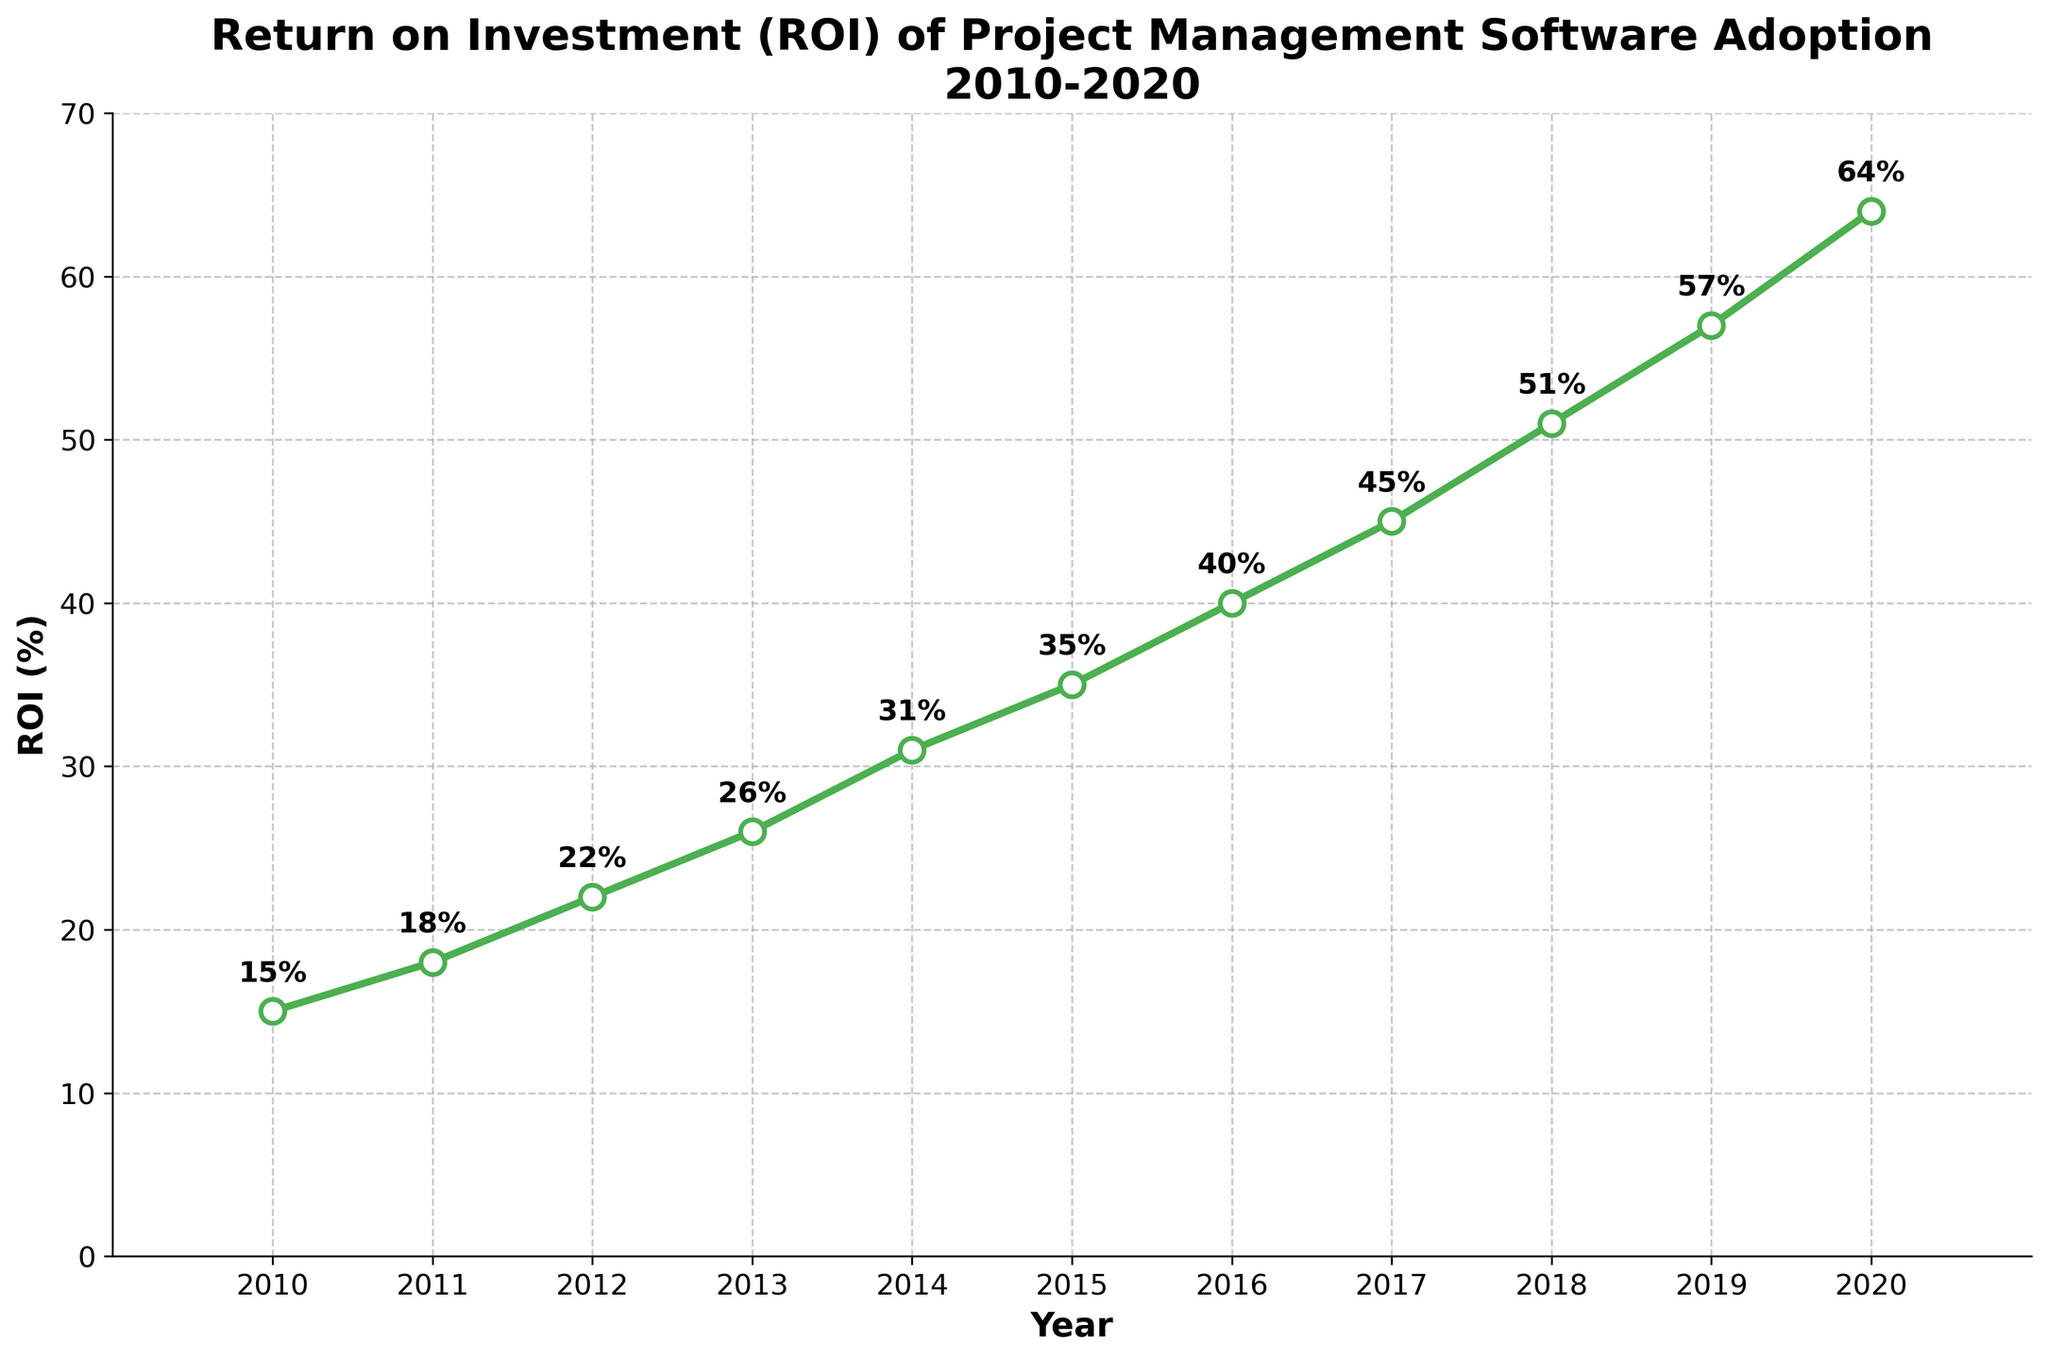What's the maximum ROI within the period? The highest point on the plot represents the maximum ROI. By looking at the y-axis values of the data points, the highest value is found at the year 2020.
Answer: 64% What's the difference in ROI between 2016 and 2020? To find the difference, locate the ROI values for 2016 and 2020 from the plot, which are 40% and 64% respectively. Then subtract the ROI of 2016 from 2020. 64% - 40% = 24%.
Answer: 24% In which year did the ROI first exceed 50%? The y-axis labels and data points show the progression of ROI over the years. The ROI first exceeds 50% at 2018 where the graph marks the ROI at 51%.
Answer: 2018 What's the average ROI over the period from 2010 to 2020? Add up all the ROI percentages from 2010 to 2020, which are 15%, 18%, 22%, 26%, 31%, 35%, 40%, 45%, 51%, 57%, and 64%. Then divide by the number of years, which is 11. (15+18+22+26+31+35+40+45+51+57+64)/11 = 36.27%.
Answer: 36.27% How much did the ROI increase from 2010 to 2011? Locate the ROI values for 2010 and 2011 from the plot, which are 15% and 18% respectively. Then subtract the ROI of 2010 from 2011. 18% - 15% = 3%.
Answer: 3% Between which two consecutive years was the smallest increase in ROI observed? Examine the differences between consecutive years by observing the distance between data points on the plot. Measure each yearly increase. The smallest increment is between 2010 and 2011 which is 3% (15% to 18%).
Answer: 2010-2011 What is the range of ROI values observed in the chart? The range is the difference between the maximum and minimum ROI values. The plot shows a minimum value of 15% in 2010 and a maximum of 64% in 2020. 64% - 15% = 49%.
Answer: 49% Which year marks the midpoint (median) of the observation period? What was the ROI in that year? The observation period from 2010 to 2020 has 11 years. The median year is the 6th year when sorted chronologically, which is 2015. The ROI in 2015 is 35%.
Answer: 2015, 35% How does the ROI trend overall across the entire period? By examining the overall direction of the plotted line, which consistently rises from 2010 to 2020, indicates a continuous increase in ROI over the years.
Answer: Increasing In what year did the ROI grow the most rapidly compared to the previous year? To determine the year with the rapid growth, compare the year-to-year increases in ROI. The largest jump occurs between 2018 and 2019 where the increase is from 51% to 57%, which is an increase of 6%.
Answer: 2019 